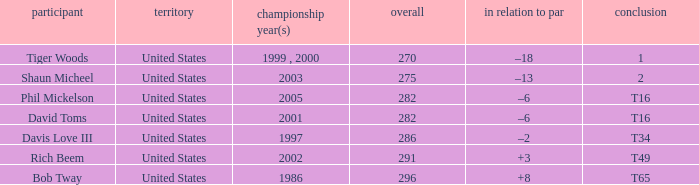In which year(s) did the person who has a total of 291 win? 2002.0. 